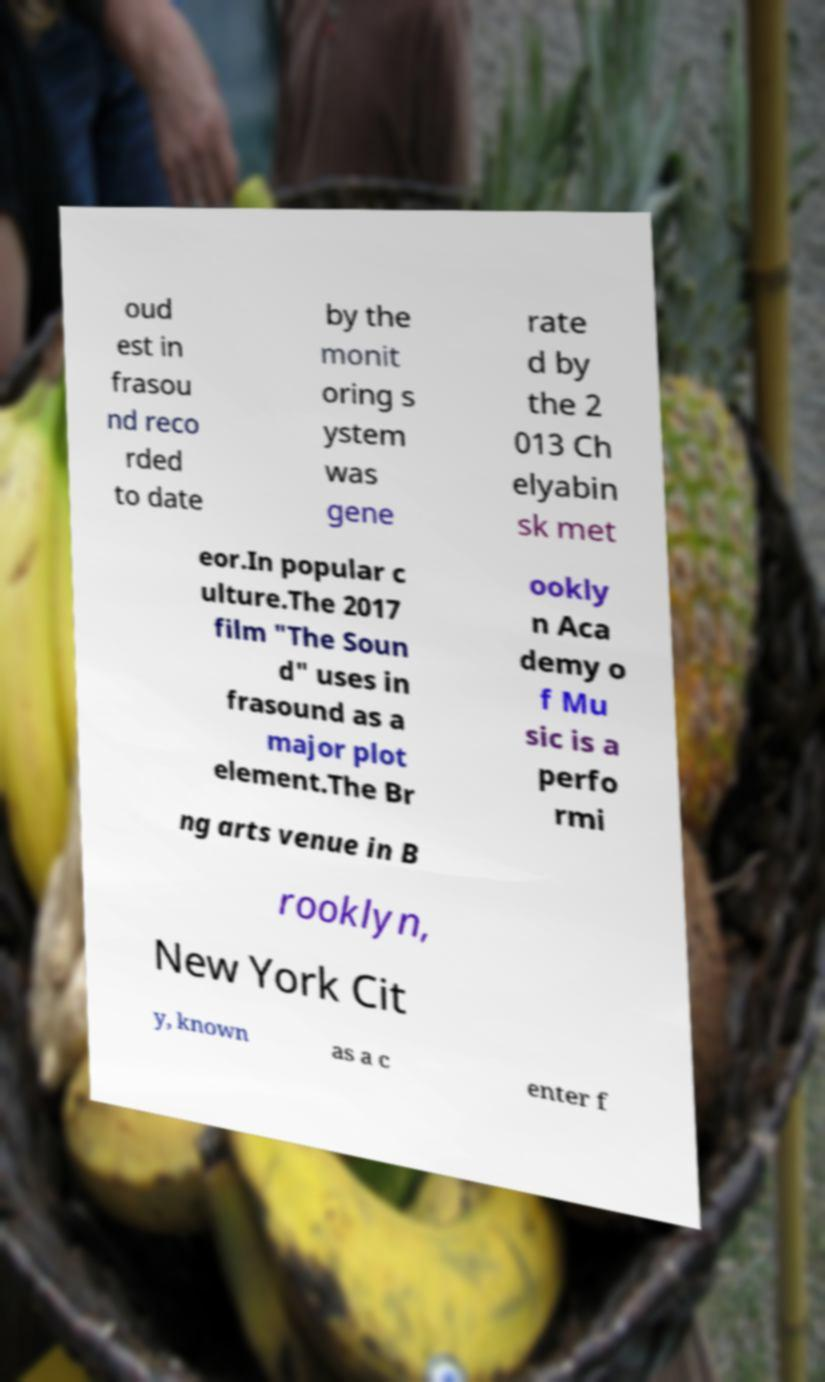For documentation purposes, I need the text within this image transcribed. Could you provide that? oud est in frasou nd reco rded to date by the monit oring s ystem was gene rate d by the 2 013 Ch elyabin sk met eor.In popular c ulture.The 2017 film "The Soun d" uses in frasound as a major plot element.The Br ookly n Aca demy o f Mu sic is a perfo rmi ng arts venue in B rooklyn, New York Cit y, known as a c enter f 